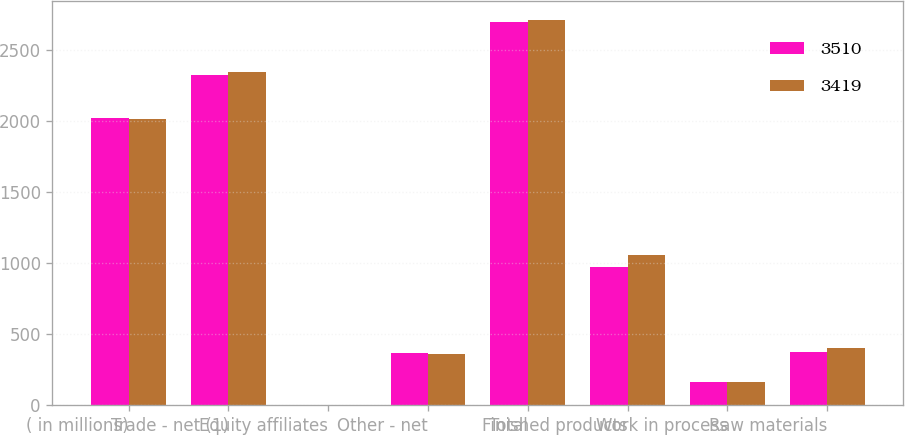Convert chart to OTSL. <chart><loc_0><loc_0><loc_500><loc_500><stacked_bar_chart><ecel><fcel>( in millions)<fcel>Trade - net (1)<fcel>Equity affiliates<fcel>Other - net<fcel>Total<fcel>Finished products<fcel>Work in process<fcel>Raw materials<nl><fcel>3510<fcel>2016<fcel>2324<fcel>3<fcel>365<fcel>2692<fcel>969<fcel>165<fcel>375<nl><fcel>3419<fcel>2015<fcel>2343<fcel>4<fcel>362<fcel>2709<fcel>1055<fcel>161<fcel>402<nl></chart> 